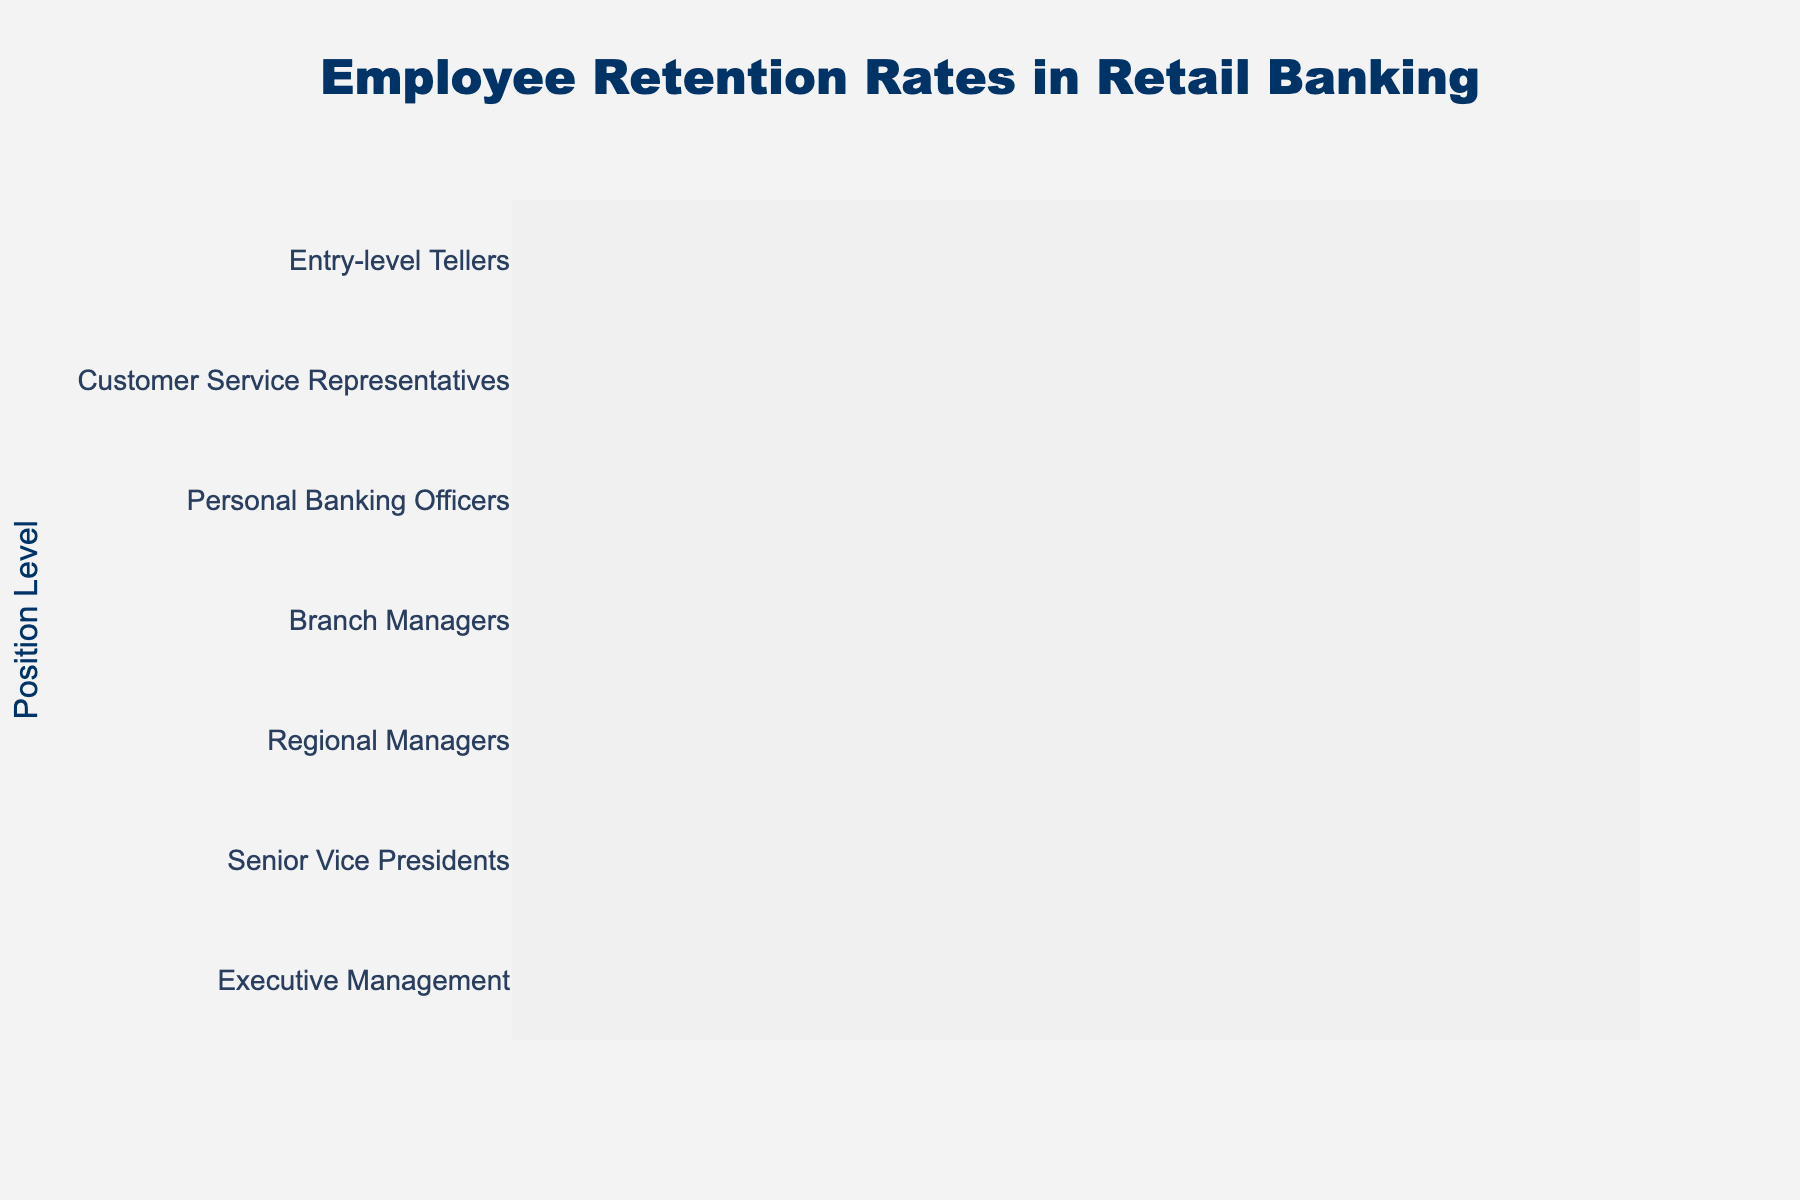What is the title of the funnel chart? The title of the chart is displayed at the top and centered. It reads "Employee Retention Rates in Retail Banking".
Answer: Employee Retention Rates in Retail Banking What is the highest retention rate shown in the chart? The retention rates are listed along the x-axis, and the highest value in the chart is 85% for Entry-level Tellers, which is the top section of the funnel.
Answer: 85% How many position levels are presented in the chart? The position levels are listed along the y-axis, and each section of the funnel represents one position level. By counting them, we find there are 7 position levels.
Answer: 7 Which position level has the lowest retention rate? By identifying the section of the funnel with the smallest value on the x-axis and looking at its corresponding y-axis label, we see that Executive Management has the lowest retention rate of 52%.
Answer: Executive Management What is the difference in retention rates between Branch Managers and Senior Vice Presidents? The retention rate for Branch Managers is 68%, and for Senior Vice Presidents, it is 58%. The difference can be calculated as 68% - 58%.
Answer: 10% What is the average retention rate across all position levels? To find the average, sum up all the retention rates and divide by the number of position levels: (85 + 78 + 72 + 68 + 62 + 58 + 52) / 7. This equals 475 / 7.
Answer: 67.86% Which positions have a retention rate higher than 70%? By examining the funnel sections with retention rates above 70%, we identify Entry-level Tellers (85%), Customer Service Representatives (78%), and Personal Banking Officers (72%).
Answer: Entry-level Tellers, Customer Service Representatives, Personal Banking Officers What is the percentage decrement in retention from Customer Service Representatives to Personal Banking Officers? Subtract the retention rate of Personal Banking Officers (72%) from that of Customer Service Representatives (78%) and then find the percentage decrease relative to Customer Service Representatives: (78 - 72) / 78 * 100.
Answer: 7.69% Between Branch Managers and Regional Managers, which position has a lower retention rate, and by how much? Branch Managers have a retention rate of 68%, and Regional Managers have 62%. The difference is 68% - 62%. Regional Managers have a lower rate by 6%.
Answer: Regional Managers, 6% 